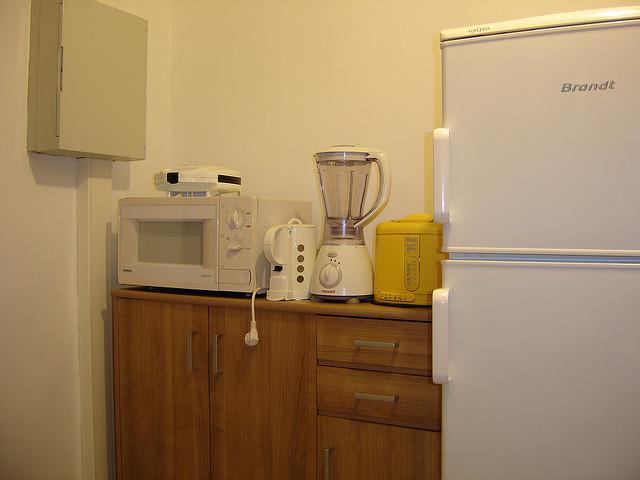What in this photo would you use to reheat coffee?
Quick response, please. Microwave. How many appliances in this photo?
Be succinct. 6. What brand appears on the refrigerator?
Be succinct. Brandt. 